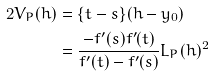Convert formula to latex. <formula><loc_0><loc_0><loc_500><loc_500>2 V _ { P } ( h ) & = \{ t - s \} ( h - y _ { 0 } ) \\ & = \frac { - f ^ { \prime } ( s ) f ^ { \prime } ( t ) } { f ^ { \prime } ( t ) - f ^ { \prime } ( s ) } L _ { P } ( h ) ^ { 2 }</formula> 